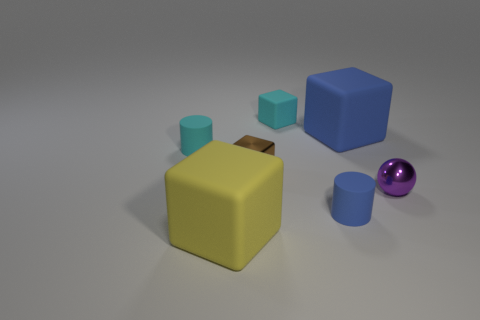There is a cyan rubber thing that is the same shape as the small brown thing; what size is it?
Provide a succinct answer. Small. Does the small thing on the left side of the tiny brown metallic object have the same shape as the large yellow object?
Provide a short and direct response. No. There is a thing that is in front of the tiny rubber thing in front of the brown thing; what shape is it?
Make the answer very short. Cube. Are there any other things that are the same shape as the small purple metallic thing?
Ensure brevity in your answer.  No. There is another object that is the same shape as the tiny blue rubber object; what is its color?
Make the answer very short. Cyan. Do the small rubber cube and the matte object that is left of the large yellow block have the same color?
Your answer should be very brief. Yes. What is the shape of the thing that is in front of the big blue object and to the right of the tiny blue thing?
Keep it short and to the point. Sphere. Are there fewer large yellow things than purple cubes?
Ensure brevity in your answer.  No. Is there a large blue metal ball?
Make the answer very short. No. How many other things are the same size as the blue rubber cylinder?
Provide a short and direct response. 4. 